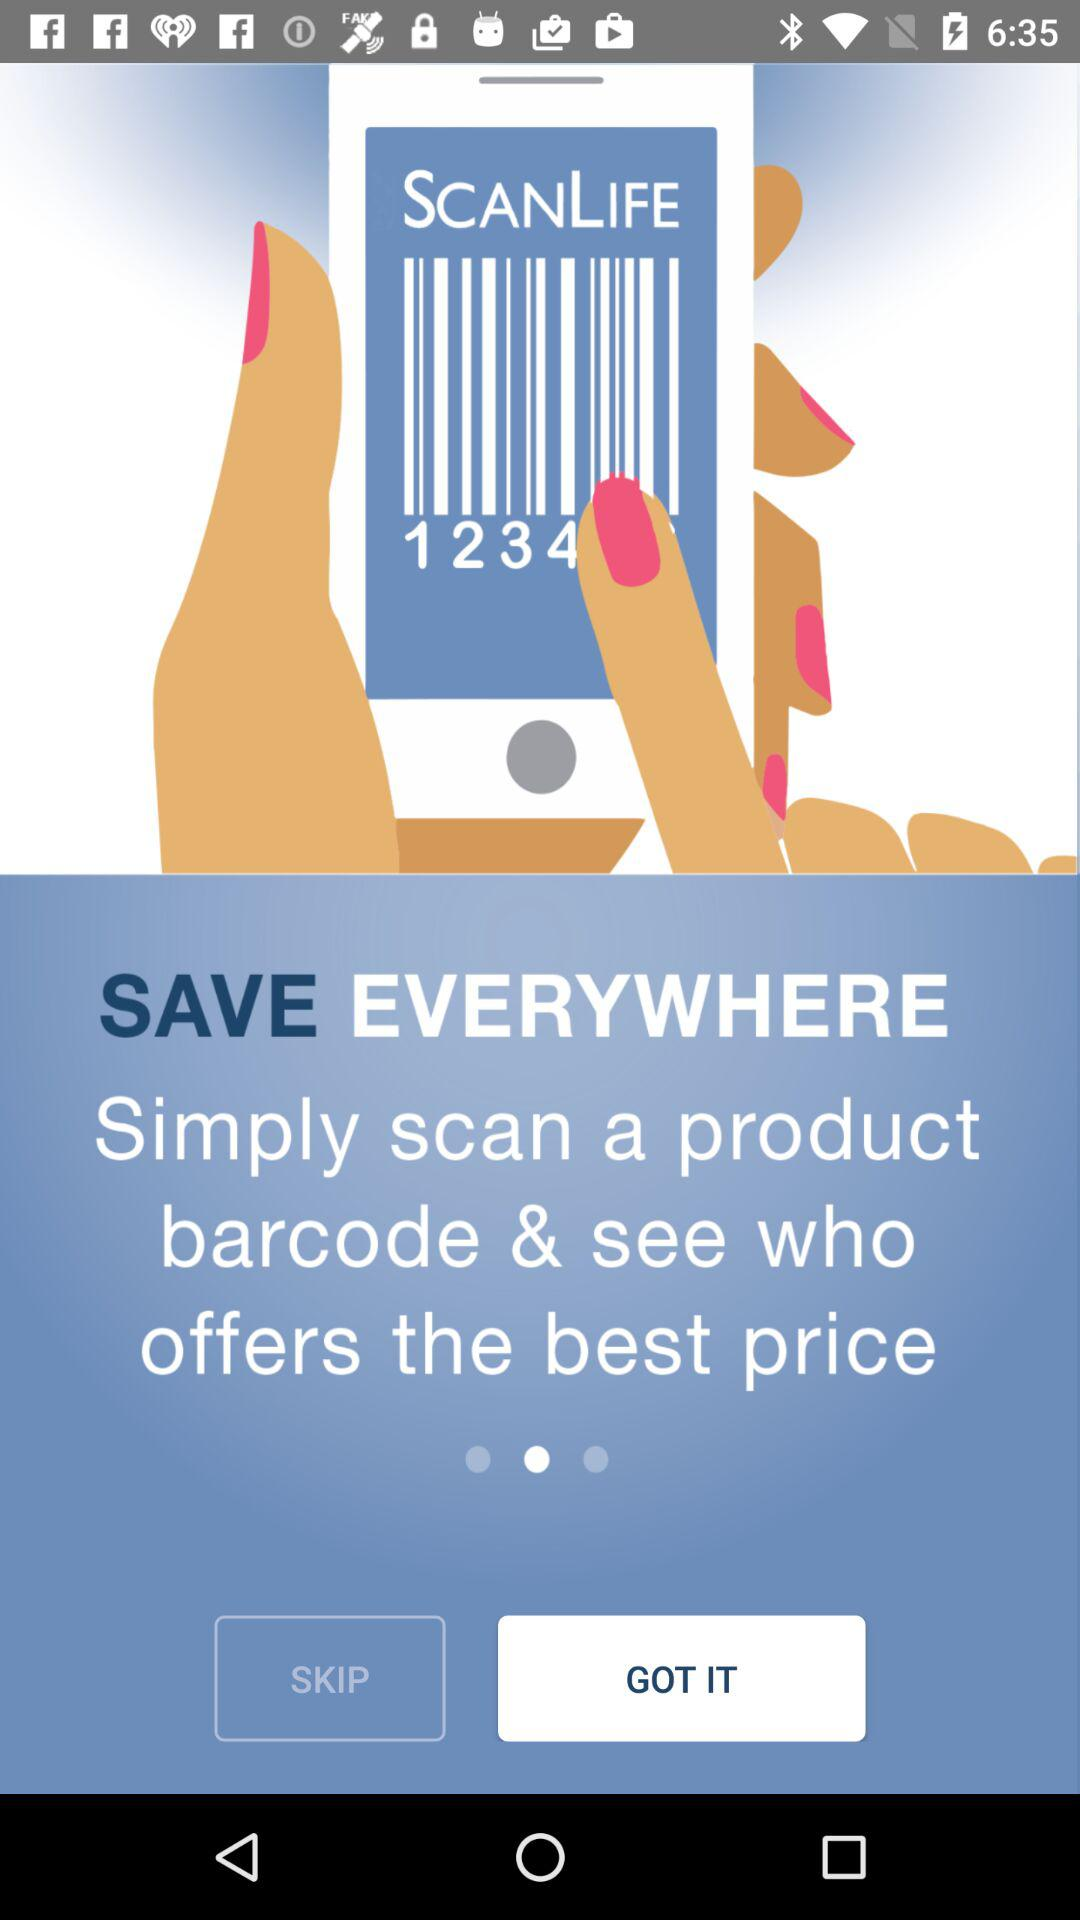Who currently offers the best price?
When the provided information is insufficient, respond with <no answer>. <no answer> 